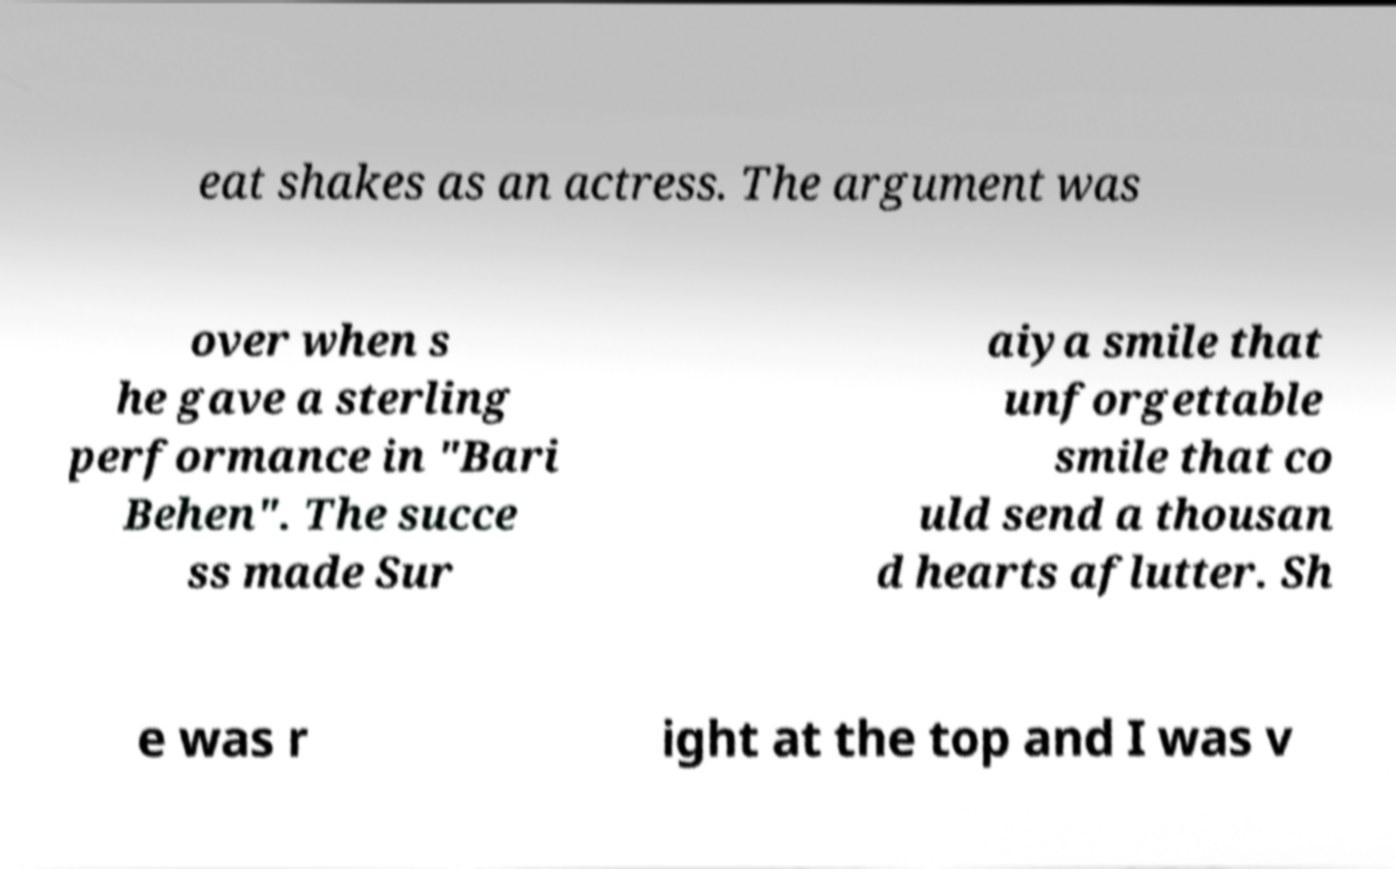Can you read and provide the text displayed in the image?This photo seems to have some interesting text. Can you extract and type it out for me? eat shakes as an actress. The argument was over when s he gave a sterling performance in "Bari Behen". The succe ss made Sur aiya smile that unforgettable smile that co uld send a thousan d hearts aflutter. Sh e was r ight at the top and I was v 